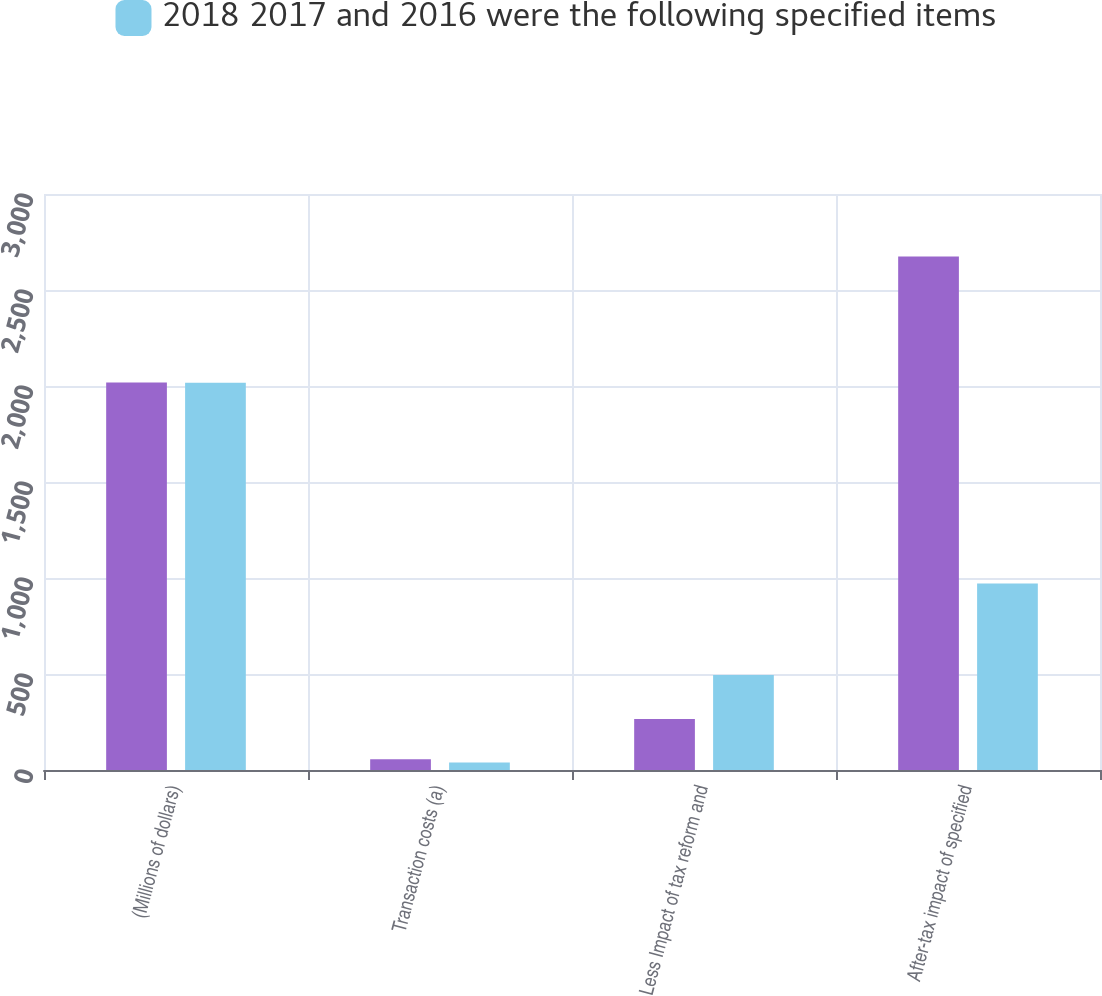Convert chart to OTSL. <chart><loc_0><loc_0><loc_500><loc_500><stacked_bar_chart><ecel><fcel>(Millions of dollars)<fcel>Transaction costs (a)<fcel>Less Impact of tax reform and<fcel>After-tax impact of specified<nl><fcel>nan<fcel>2018<fcel>56<fcel>265<fcel>2674<nl><fcel>2018 2017 and 2016 were the following specified items<fcel>2017<fcel>39<fcel>495<fcel>971<nl></chart> 